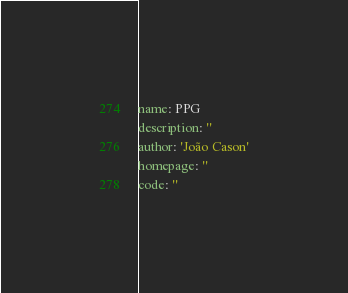Convert code to text. <code><loc_0><loc_0><loc_500><loc_500><_YAML_>name: PPG
description: ''
author: 'João Cason'
homepage: ''
code: ''
</code> 